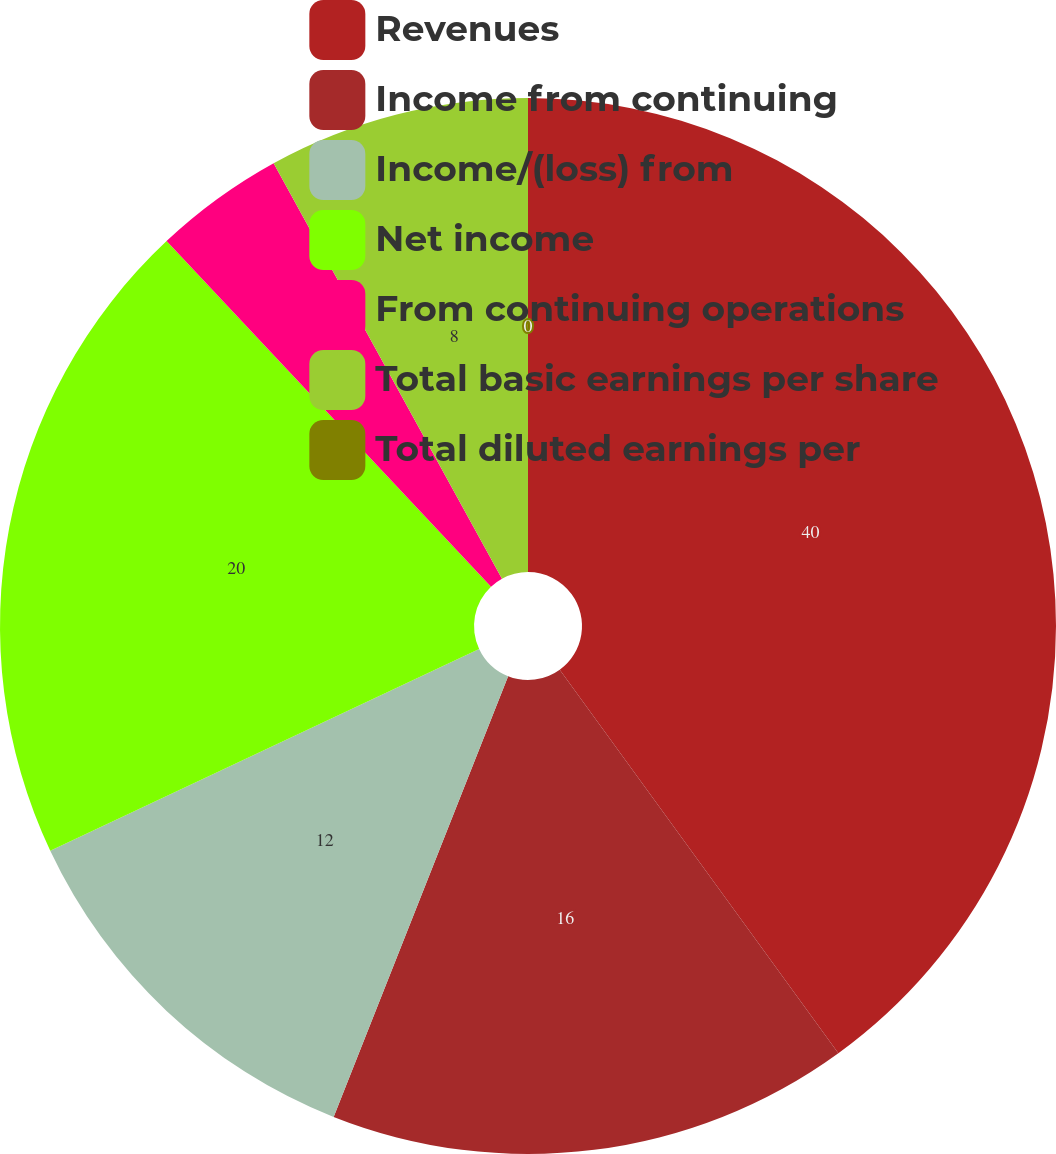<chart> <loc_0><loc_0><loc_500><loc_500><pie_chart><fcel>Revenues<fcel>Income from continuing<fcel>Income/(loss) from<fcel>Net income<fcel>From continuing operations<fcel>Total basic earnings per share<fcel>Total diluted earnings per<nl><fcel>40.0%<fcel>16.0%<fcel>12.0%<fcel>20.0%<fcel>4.0%<fcel>8.0%<fcel>0.0%<nl></chart> 